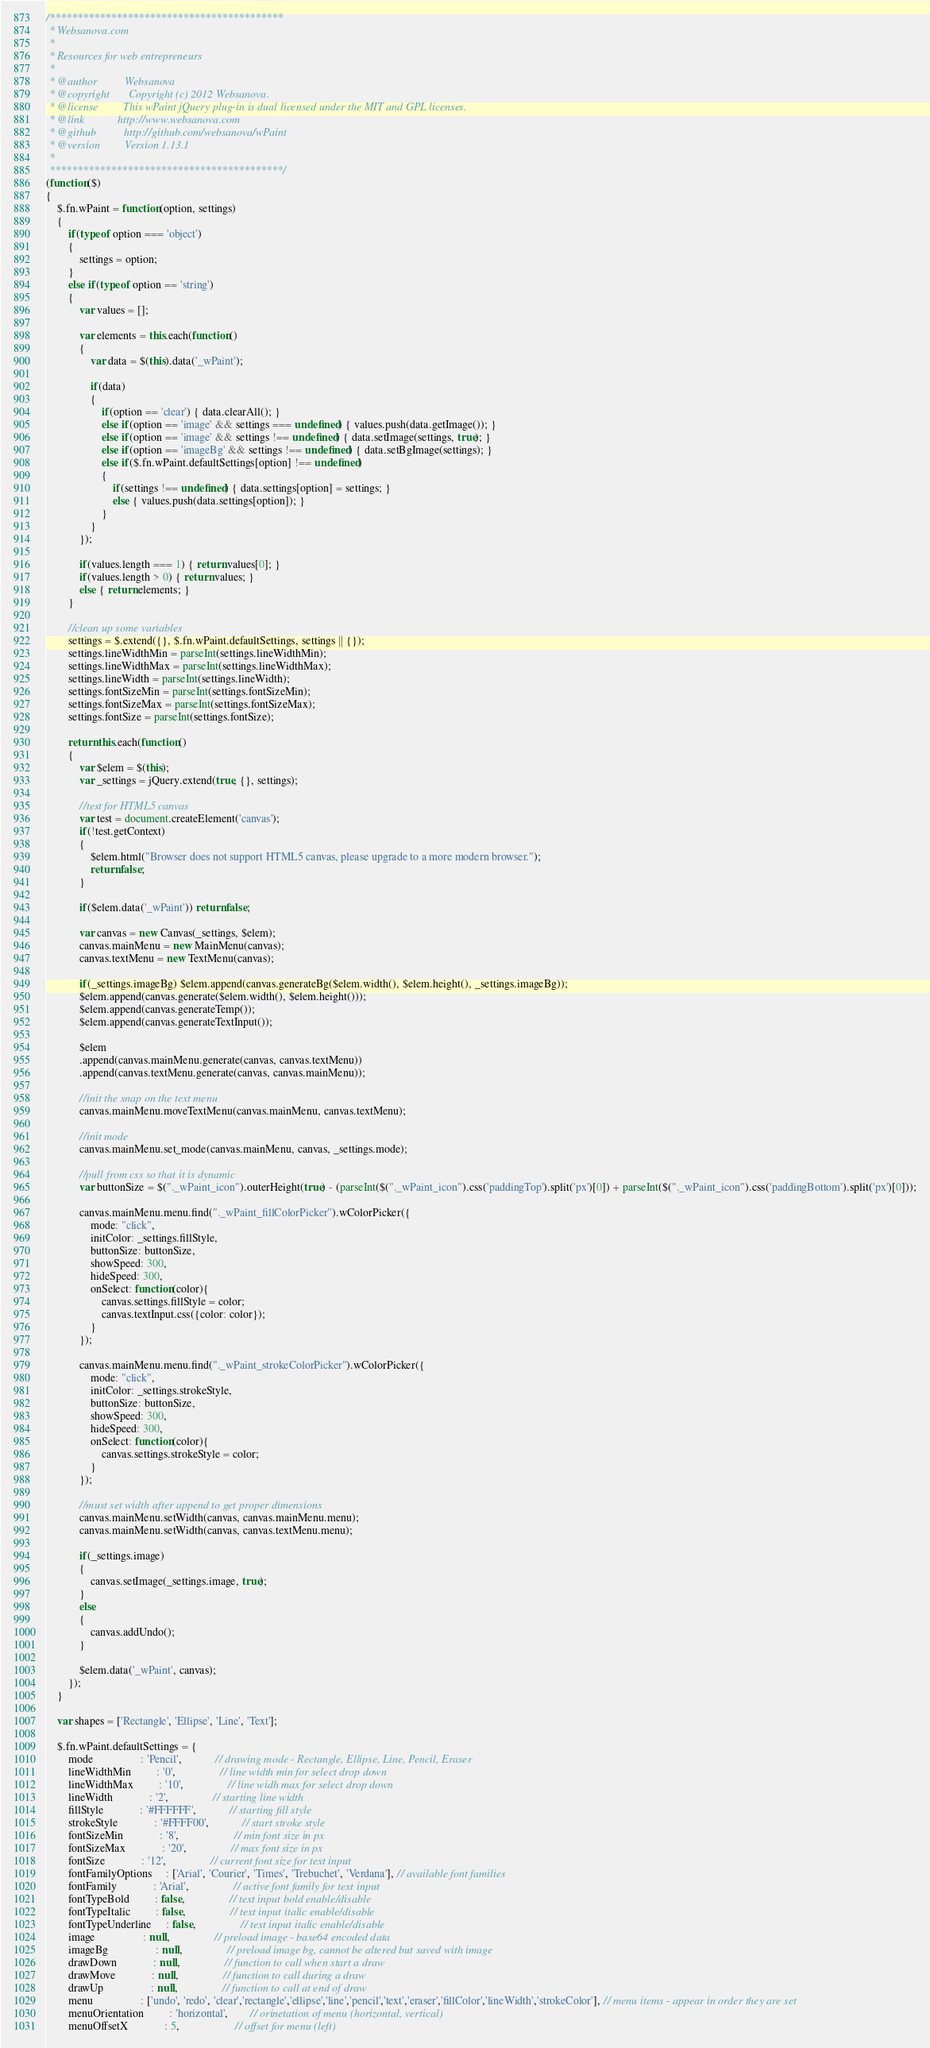Convert code to text. <code><loc_0><loc_0><loc_500><loc_500><_JavaScript_>/******************************************
 * Websanova.com
 *
 * Resources for web entrepreneurs
 *
 * @author          Websanova
 * @copyright       Copyright (c) 2012 Websanova.
 * @license         This wPaint jQuery plug-in is dual licensed under the MIT and GPL licenses.
 * @link            http://www.websanova.com
 * @github			http://github.com/websanova/wPaint
 * @version         Version 1.13.1
 *
 ******************************************/
(function($)
{
	$.fn.wPaint = function(option, settings)
	{
		if(typeof option === 'object')
		{
			settings = option;
		}
		else if(typeof option == 'string')
		{
			var values = [];

			var elements = this.each(function()
			{
				var data = $(this).data('_wPaint');

				if(data)
				{
					if(option == 'clear') { data.clearAll(); }
					else if(option == 'image' && settings === undefined) { values.push(data.getImage()); }
					else if(option == 'image' && settings !== undefined) { data.setImage(settings, true); }
					else if(option == 'imageBg' && settings !== undefined) { data.setBgImage(settings); }
					else if($.fn.wPaint.defaultSettings[option] !== undefined)
					{
						if(settings !== undefined) { data.settings[option] = settings; }
						else { values.push(data.settings[option]); }
					}
				}
			});

			if(values.length === 1) { return values[0]; }
			if(values.length > 0) { return values; }
			else { return elements; }
		}

		//clean up some variables
		settings = $.extend({}, $.fn.wPaint.defaultSettings, settings || {});
		settings.lineWidthMin = parseInt(settings.lineWidthMin);
		settings.lineWidthMax = parseInt(settings.lineWidthMax);
		settings.lineWidth = parseInt(settings.lineWidth);
		settings.fontSizeMin = parseInt(settings.fontSizeMin);
		settings.fontSizeMax = parseInt(settings.fontSizeMax);
		settings.fontSize = parseInt(settings.fontSize);
		
		return this.each(function()
		{			
			var $elem = $(this);
			var _settings = jQuery.extend(true, {}, settings);
			
			//test for HTML5 canvas
			var test = document.createElement('canvas');
			if(!test.getContext)
			{
				$elem.html("Browser does not support HTML5 canvas, please upgrade to a more modern browser.");
				return false;	
			}
			
			if($elem.data('_wPaint')) return false;

			var canvas = new Canvas(_settings, $elem);
			canvas.mainMenu = new MainMenu(canvas);
			canvas.textMenu = new TextMenu(canvas);
			
			if(_settings.imageBg) $elem.append(canvas.generateBg($elem.width(), $elem.height(), _settings.imageBg));
			$elem.append(canvas.generate($elem.width(), $elem.height()));
			$elem.append(canvas.generateTemp());
			$elem.append(canvas.generateTextInput());

			$elem
			.append(canvas.mainMenu.generate(canvas, canvas.textMenu))
			.append(canvas.textMenu.generate(canvas, canvas.mainMenu));

			//init the snap on the text menu
			canvas.mainMenu.moveTextMenu(canvas.mainMenu, canvas.textMenu);

			//init mode
			canvas.mainMenu.set_mode(canvas.mainMenu, canvas, _settings.mode);

			//pull from css so that it is dynamic
			var buttonSize = $("._wPaint_icon").outerHeight(true) - (parseInt($("._wPaint_icon").css('paddingTop').split('px')[0]) + parseInt($("._wPaint_icon").css('paddingBottom').split('px')[0]));

			canvas.mainMenu.menu.find("._wPaint_fillColorPicker").wColorPicker({
				mode: "click",
				initColor: _settings.fillStyle,
				buttonSize: buttonSize,
				showSpeed: 300,
				hideSpeed: 300,
				onSelect: function(color){
					canvas.settings.fillStyle = color;
					canvas.textInput.css({color: color});
				}
			});
			
			canvas.mainMenu.menu.find("._wPaint_strokeColorPicker").wColorPicker({
				mode: "click",
				initColor: _settings.strokeStyle,
				buttonSize: buttonSize,
				showSpeed: 300,
				hideSpeed: 300,
				onSelect: function(color){
					canvas.settings.strokeStyle = color;
				}
			});
			
			//must set width after append to get proper dimensions
			canvas.mainMenu.setWidth(canvas, canvas.mainMenu.menu);
			canvas.mainMenu.setWidth(canvas, canvas.textMenu.menu);

			if(_settings.image)
			{
				canvas.setImage(_settings.image, true);
			}
			else
			{
				canvas.addUndo();
			}

			$elem.data('_wPaint', canvas);
		});
	}

	var shapes = ['Rectangle', 'Ellipse', 'Line', 'Text'];

	$.fn.wPaint.defaultSettings = {
		mode				 : 'Pencil',			// drawing mode - Rectangle, Ellipse, Line, Pencil, Eraser
		lineWidthMin		 : '0', 				// line width min for select drop down
		lineWidthMax		 : '10',				// line widh max for select drop down
		lineWidth			 : '2', 				// starting line width
		fillStyle			 : '#FFFFFF',			// starting fill style
		strokeStyle			 : '#FFFF00',			// start stroke style
		fontSizeMin			 : '8',					// min font size in px
		fontSizeMax			 : '20',				// max font size in px
		fontSize			 : '12',				// current font size for text input
		fontFamilyOptions	 : ['Arial', 'Courier', 'Times', 'Trebuchet', 'Verdana'], // available font families
		fontFamily			 : 'Arial',				// active font family for text input
		fontTypeBold		 : false,				// text input bold enable/disable
		fontTypeItalic		 : false,				// text input italic enable/disable
		fontTypeUnderline	 : false,				// text input italic enable/disable
		image				 : null,				// preload image - base64 encoded data
		imageBg				 : null,				// preload image bg, cannot be altered but saved with image
		drawDown			 : null,				// function to call when start a draw
		drawMove			 : null,				// function to call during a draw
		drawUp				 : null,				// function to call at end of draw
		menu 				 : ['undo', 'redo', 'clear','rectangle','ellipse','line','pencil','text','eraser','fillColor','lineWidth','strokeColor'], // menu items - appear in order they are set
		menuOrientation		 : 'horizontal',		// orinetation of menu (horizontal, vertical)
		menuOffsetX			 : 5,					// offset for menu (left)</code> 